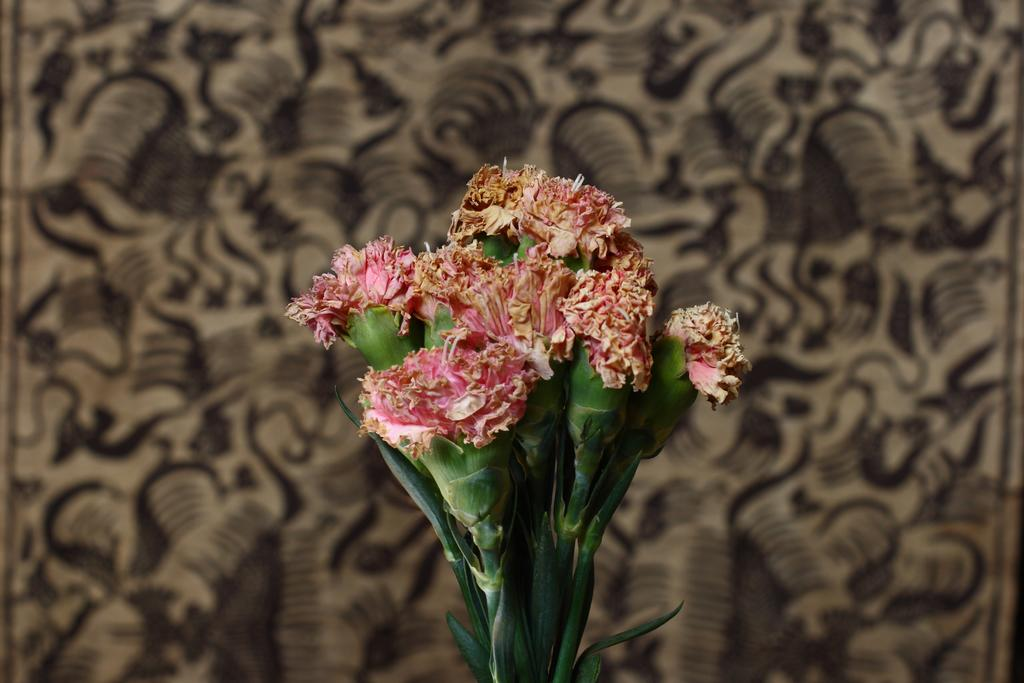What type of plants can be seen in the image? There are flowers in the image. What can be seen on the wall in the image? There is a wall with a design in the image. How many sheep are visible in the image? There are no sheep present in the image. What type of self-care product is being used by the person in the image? There is no person present in the image, so it is not possible to determine what type of self-care product they might be using. 